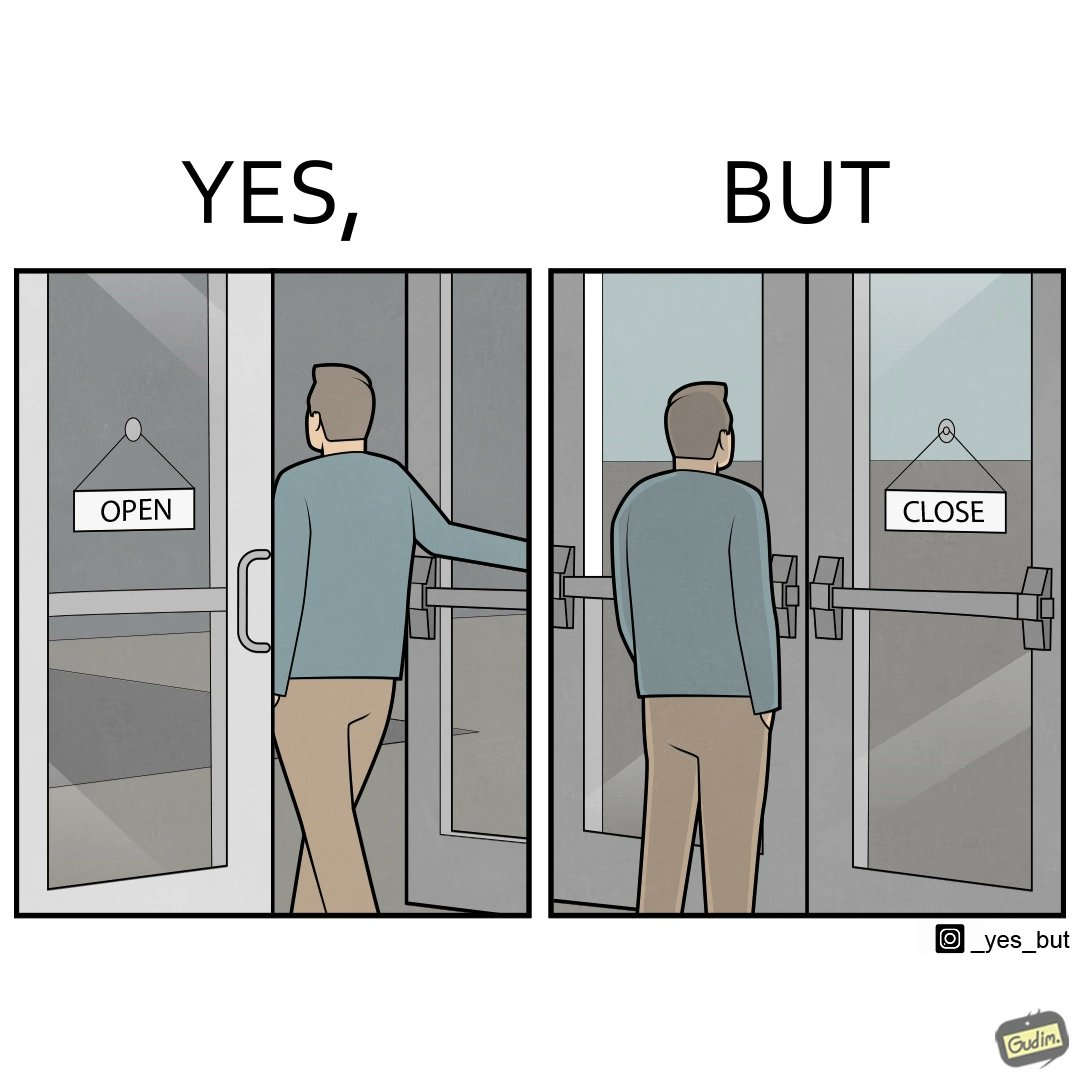Would you classify this image as satirical? Yes, this image is satirical. 